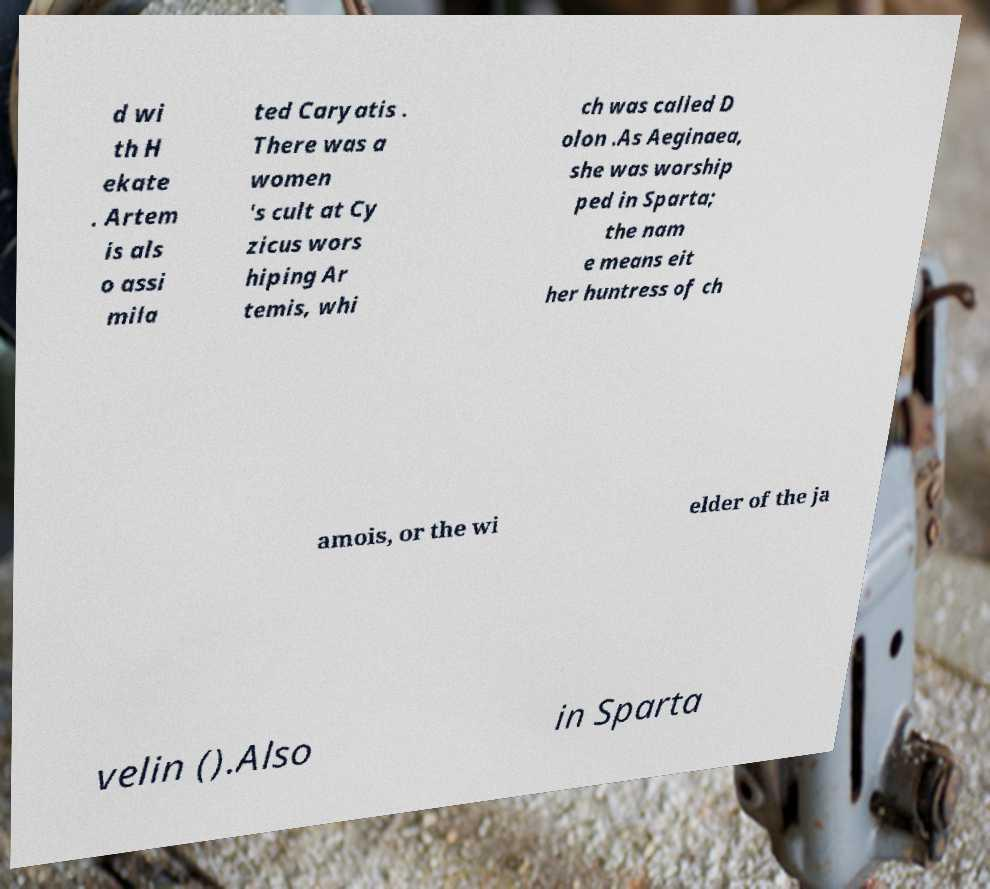For documentation purposes, I need the text within this image transcribed. Could you provide that? d wi th H ekate . Artem is als o assi mila ted Caryatis . There was a women 's cult at Cy zicus wors hiping Ar temis, whi ch was called D olon .As Aeginaea, she was worship ped in Sparta; the nam e means eit her huntress of ch amois, or the wi elder of the ja velin ().Also in Sparta 